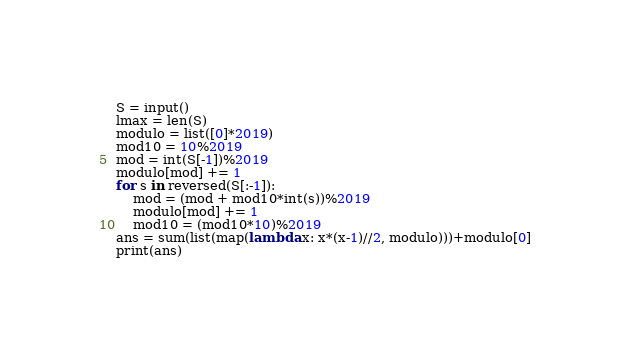<code> <loc_0><loc_0><loc_500><loc_500><_Python_>S = input()
lmax = len(S)
modulo = list([0]*2019)
mod10 = 10%2019
mod = int(S[-1])%2019
modulo[mod] += 1
for s in reversed(S[:-1]):
    mod = (mod + mod10*int(s))%2019
    modulo[mod] += 1
    mod10 = (mod10*10)%2019
ans = sum(list(map(lambda x: x*(x-1)//2, modulo)))+modulo[0]
print(ans)</code> 